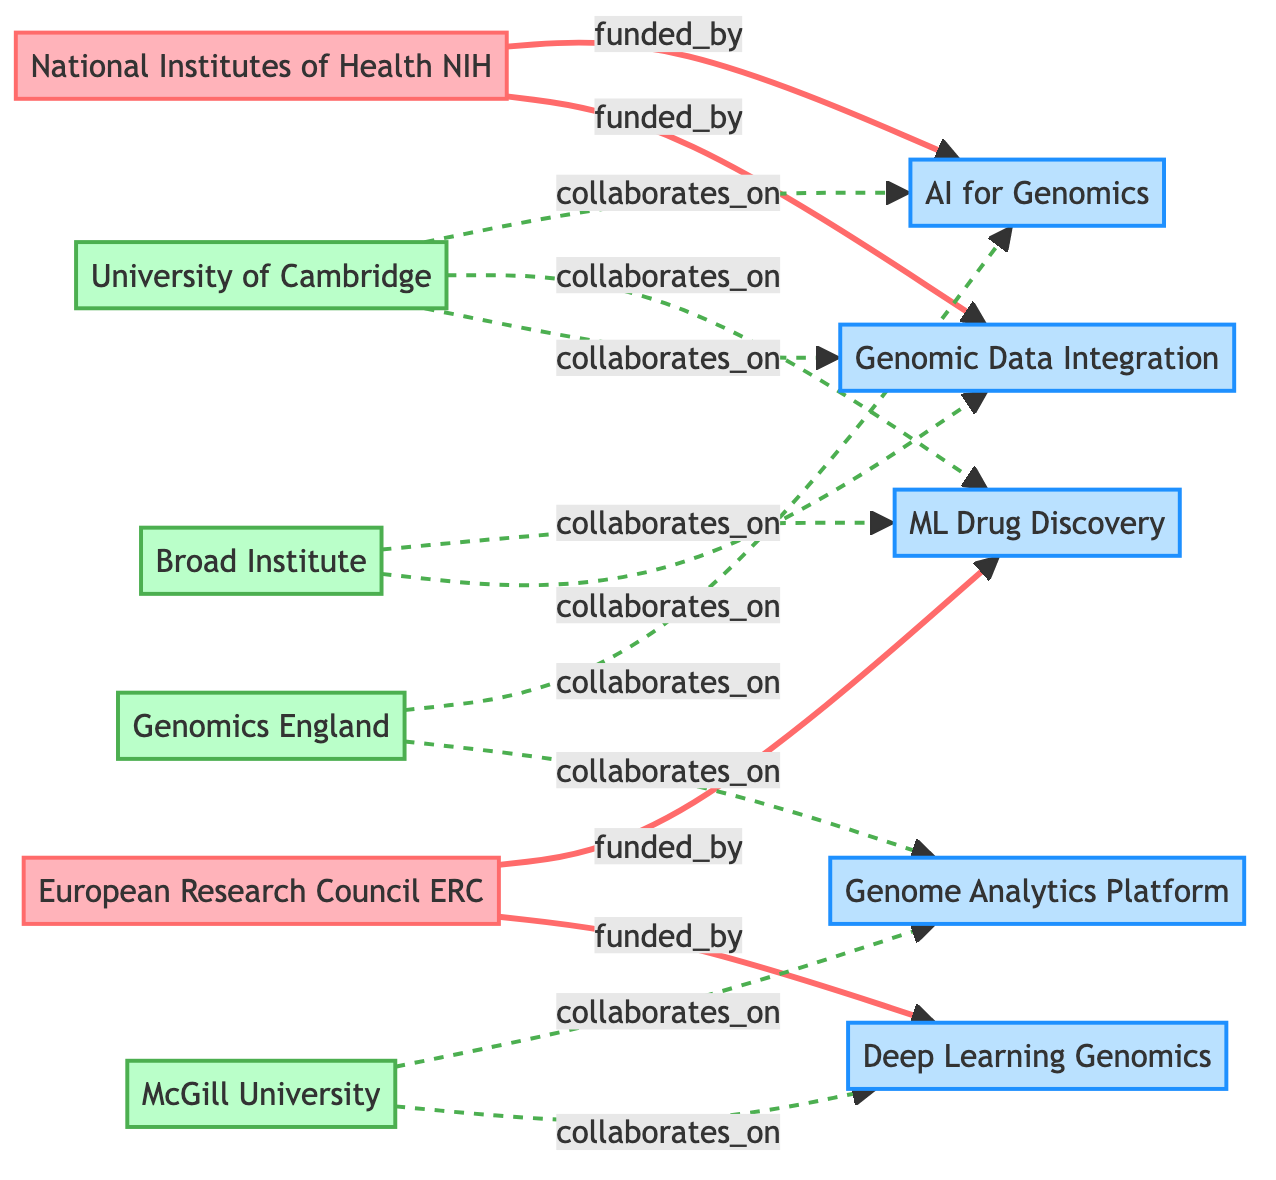What funding agency is linked to the project "AI for Genomics"? The diagram shows a direct link from the "National Institutes of Health NIH" node to the project "AI for Genomics". Therefore, the funding agency linked to this project is NIH.
Answer: National Institutes of Health NIH How many research institutions are collaborating on "Genome Analytics Platform"? The diagram shows two collaborative links associated with "Genome Analytics Platform": one from "Genomics England" and one from "McGill University". Therefore, there are two research institutions collaborating on this project.
Answer: 2 Which research project has the highest number of collaborations? By analyzing the collaborative links in the diagram, "Genomic Data Integration" has links from "Genomics England" and "Broad Institute". Therefore, its two collaborations make it among the highest. However, "Genome Analytics Platform" also has two links, so we need to evaluate both closely together. Since both projects have the same number of collaborations, we can consider them equally high.
Answer: Genomic Data Integration and Genome Analytics Platform What is the relationship type between "McGill University" and "Deep Learning Genomics"? The diagram illustrates no direct links between "McGill University" and "Deep Learning Genomics". Instead, "McGill University" collaborates on "Deep Learning Genomics" through a dashed line, indicating a collaborative relationship.
Answer: collaborates on How many total projects are funded by agencies in the diagram? Counting the projects linked directly to funding agencies, we see that there are five projects funded: "AI for Genomics", "Genomic Data Integration", "ML Drug Discovery", "Deep Learning Genomics", and "Genome Analytics Platform". Thus, the total number funded amounts to five.
Answer: 5 What is the total number of edges connecting research institutions and projects? The diagram contains connections between institutions and projects. The edges count from "Genomics England" to two projects, "Broad Institute" to two projects, "McGill University" to two projects, and "University of Cambridge" to three projects. Summing these produces a total of nine edges.
Answer: 9 Which funding agency collaborates with "ML Drug Discovery"? By inspecting the links, we see that "ML Drug Discovery" is linked only to "European Research Council ERC" through a funding arrow. This means the only funding agency collaborating on "ML Drug Discovery" is ERC.
Answer: European Research Council ERC Which project is not funded by the NIH? Observing the funding links shows that the project "ML Drug Discovery" is directly linked only to the European Research Council and does not have a direct connecting link to the NIH. Hence, this project is not funded by the NIH.
Answer: ML Drug Discovery 